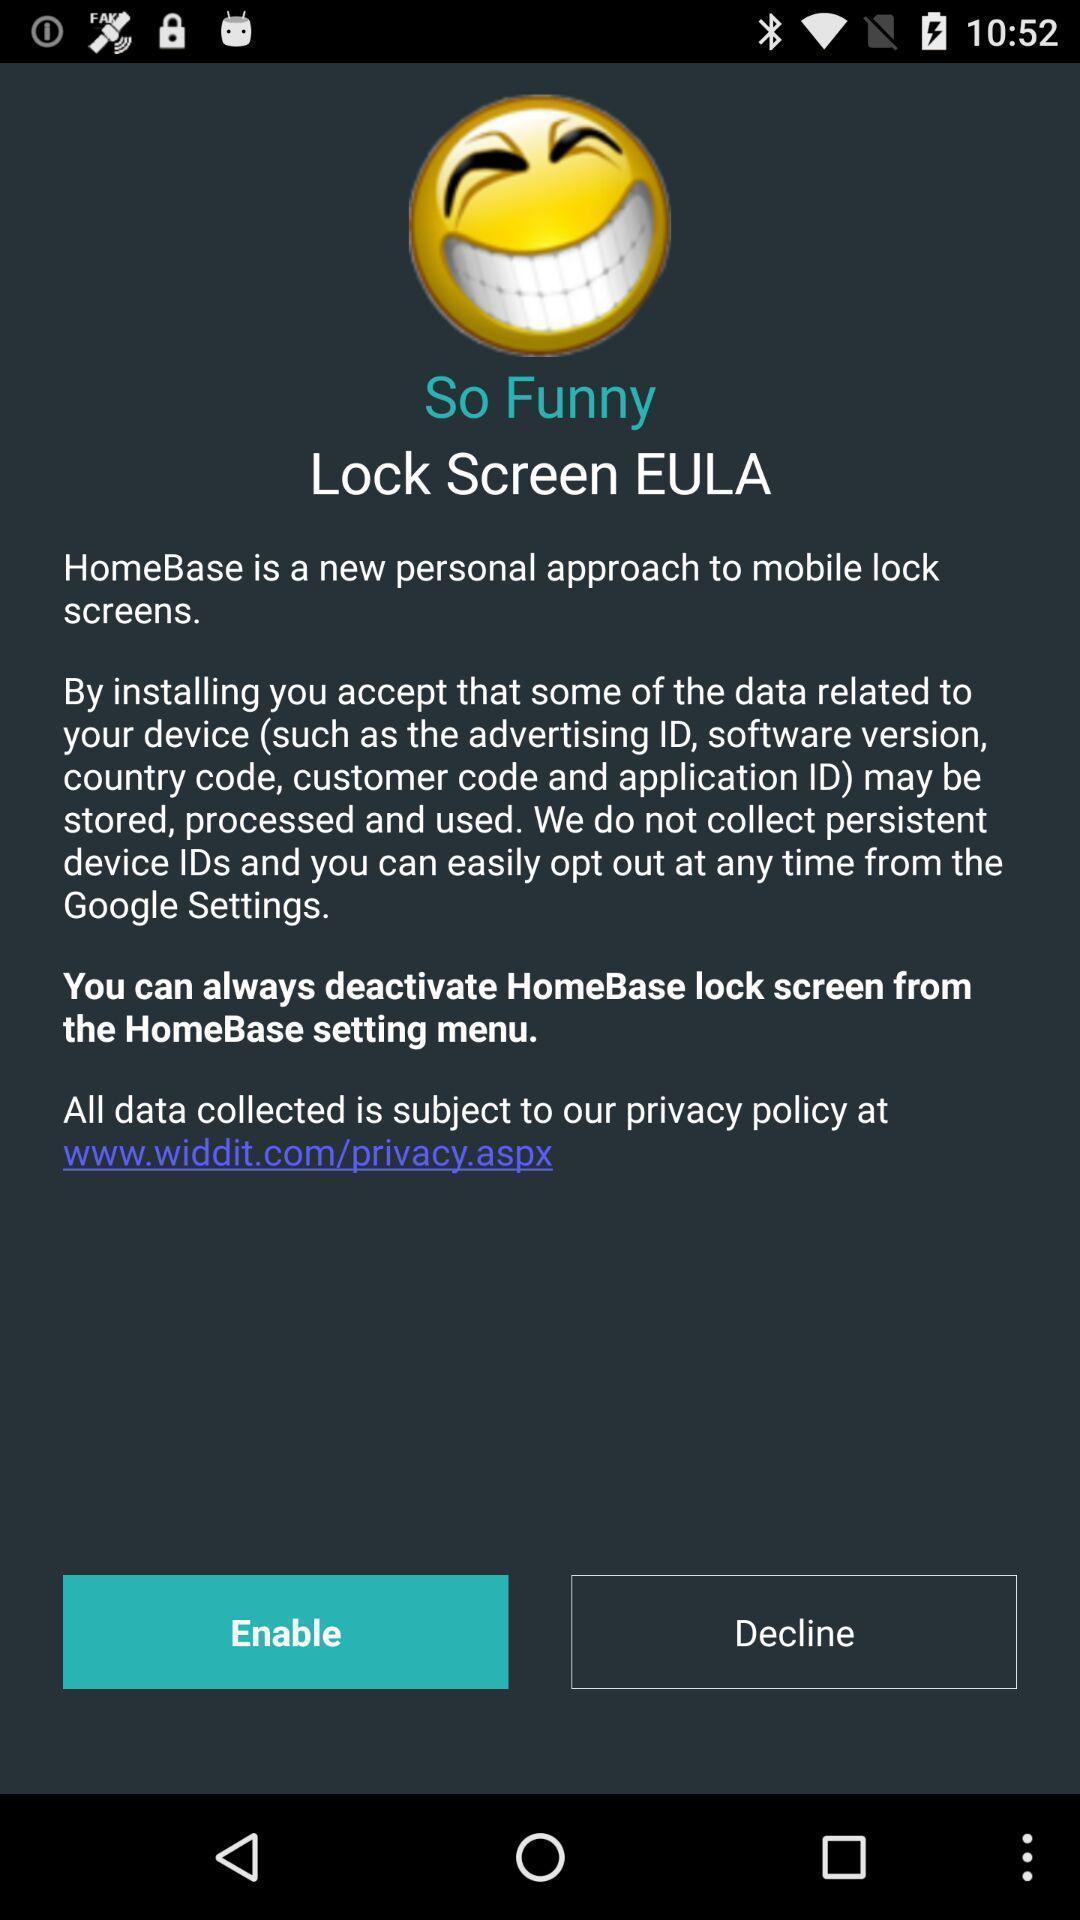Explain what's happening in this screen capture. Welcome page of a social app. 